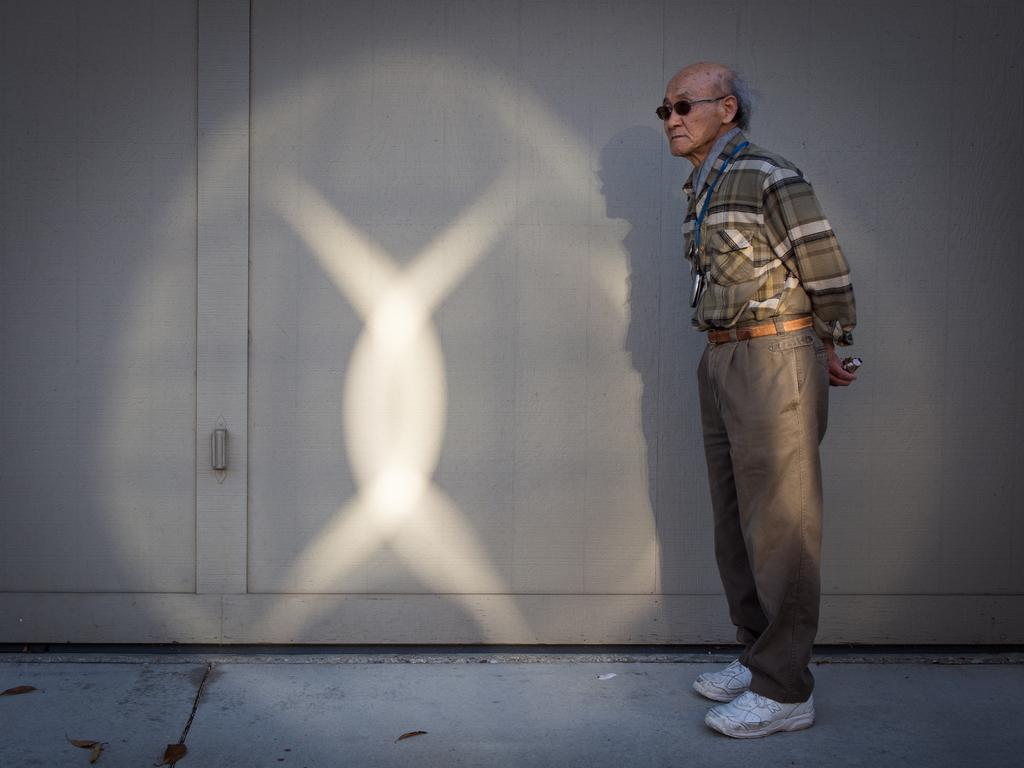What is the main subject of the image? There is a man standing in the image. Can you describe the man's appearance? The man is wearing a tag. What can be seen in the background of the image? There is a wall visible in the image. What object has a handle in the image? The presence of a handle is mentioned, but the specific object it belongs to is not clear from the provided facts. How many teeth can be seen in the image? There is no mention of teeth or any dental-related objects in the image, so it is not possible to determine the number of teeth visible. 